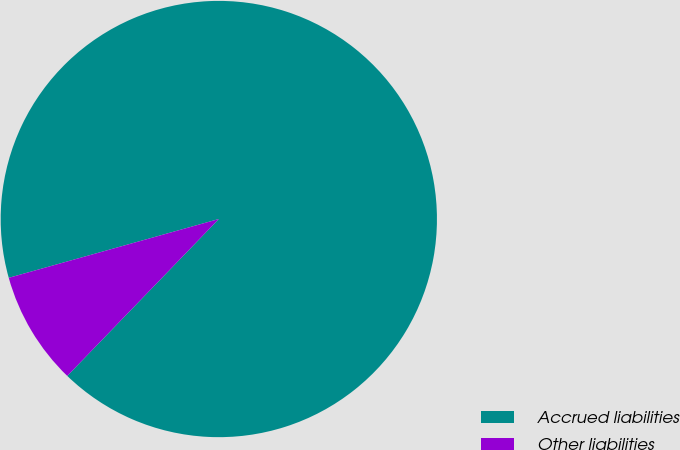Convert chart to OTSL. <chart><loc_0><loc_0><loc_500><loc_500><pie_chart><fcel>Accrued liabilities<fcel>Other liabilities<nl><fcel>91.57%<fcel>8.43%<nl></chart> 